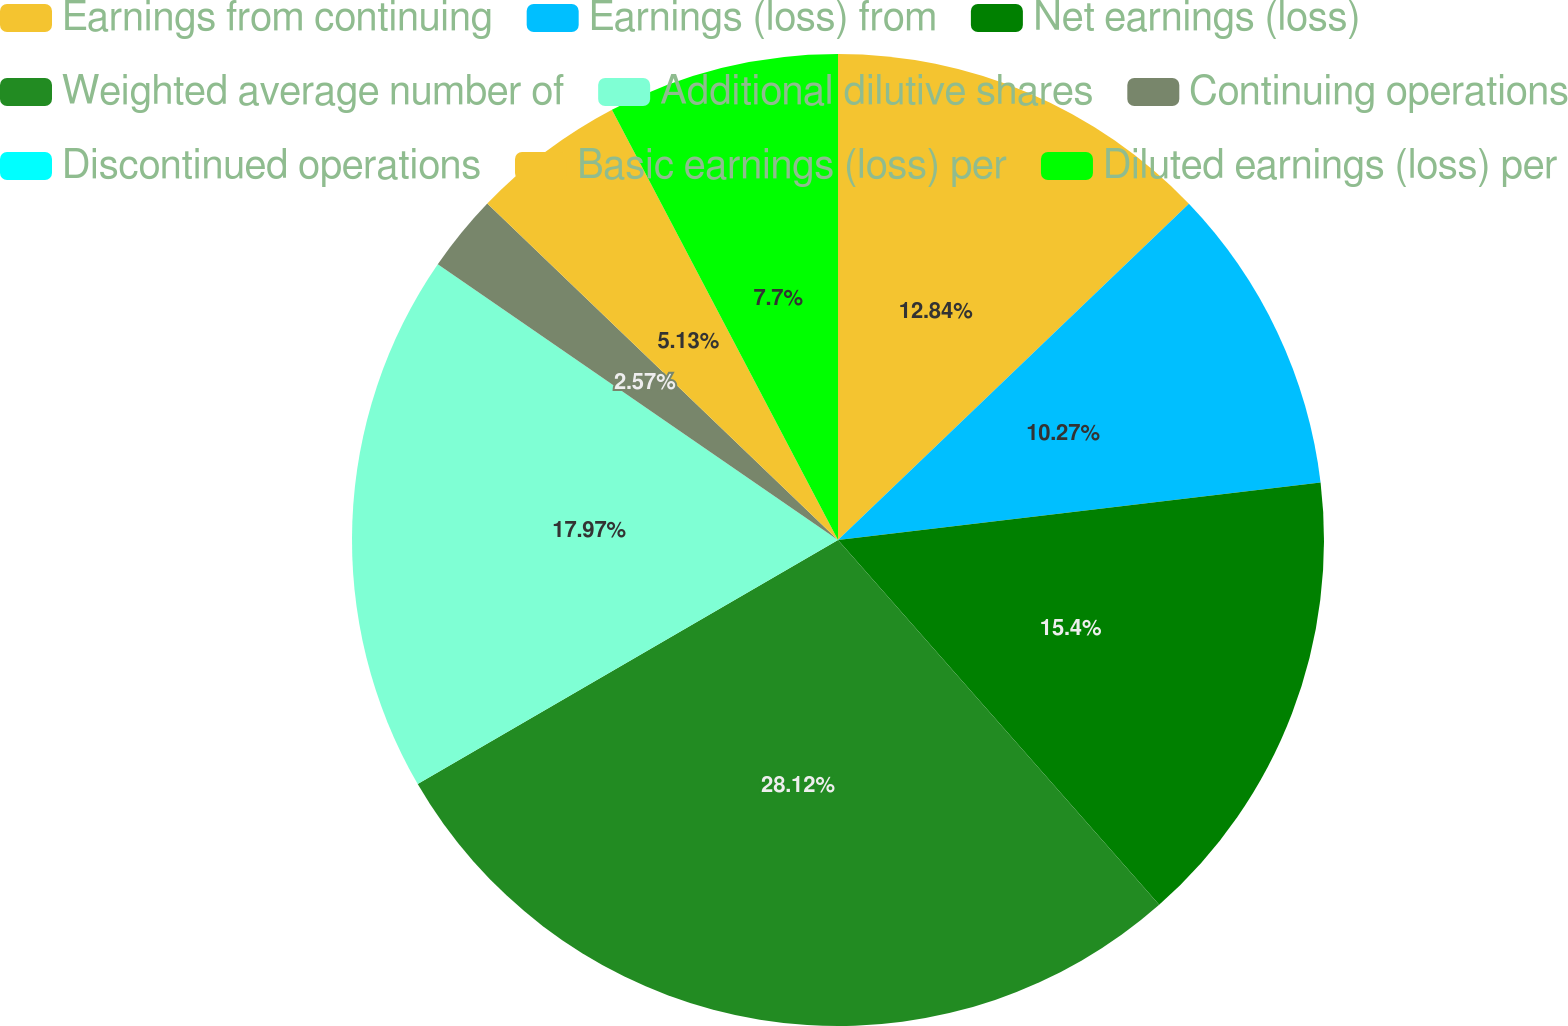Convert chart to OTSL. <chart><loc_0><loc_0><loc_500><loc_500><pie_chart><fcel>Earnings from continuing<fcel>Earnings (loss) from<fcel>Net earnings (loss)<fcel>Weighted average number of<fcel>Additional dilutive shares<fcel>Continuing operations<fcel>Discontinued operations<fcel>Basic earnings (loss) per<fcel>Diluted earnings (loss) per<nl><fcel>12.84%<fcel>10.27%<fcel>15.4%<fcel>28.12%<fcel>17.97%<fcel>2.57%<fcel>0.0%<fcel>5.13%<fcel>7.7%<nl></chart> 